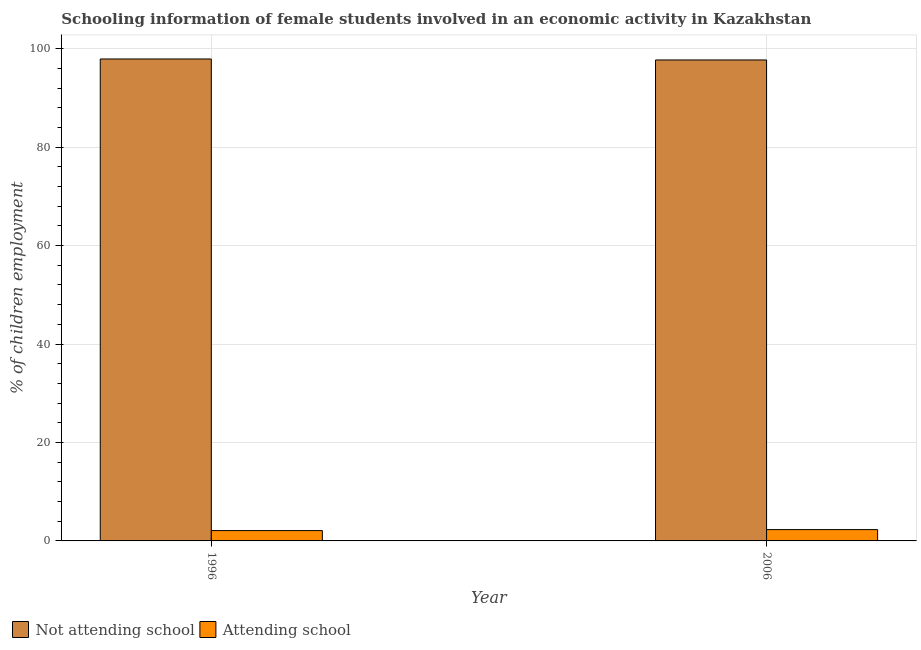How many different coloured bars are there?
Your answer should be very brief. 2. How many bars are there on the 2nd tick from the left?
Give a very brief answer. 2. How many bars are there on the 1st tick from the right?
Keep it short and to the point. 2. In how many cases, is the number of bars for a given year not equal to the number of legend labels?
Ensure brevity in your answer.  0. What is the percentage of employed females who are not attending school in 2006?
Provide a succinct answer. 97.7. Across all years, what is the minimum percentage of employed females who are not attending school?
Make the answer very short. 97.7. What is the total percentage of employed females who are not attending school in the graph?
Your answer should be very brief. 195.6. What is the difference between the percentage of employed females who are attending school in 1996 and that in 2006?
Offer a very short reply. -0.2. What is the difference between the percentage of employed females who are attending school in 2006 and the percentage of employed females who are not attending school in 1996?
Offer a very short reply. 0.2. What is the average percentage of employed females who are attending school per year?
Offer a terse response. 2.2. What is the ratio of the percentage of employed females who are not attending school in 1996 to that in 2006?
Your answer should be compact. 1. Is the percentage of employed females who are not attending school in 1996 less than that in 2006?
Your response must be concise. No. What does the 2nd bar from the left in 2006 represents?
Offer a terse response. Attending school. What does the 1st bar from the right in 2006 represents?
Your answer should be compact. Attending school. Are all the bars in the graph horizontal?
Give a very brief answer. No. What is the difference between two consecutive major ticks on the Y-axis?
Ensure brevity in your answer.  20. Are the values on the major ticks of Y-axis written in scientific E-notation?
Your answer should be very brief. No. Does the graph contain grids?
Your answer should be very brief. Yes. Where does the legend appear in the graph?
Provide a short and direct response. Bottom left. How many legend labels are there?
Make the answer very short. 2. What is the title of the graph?
Your answer should be compact. Schooling information of female students involved in an economic activity in Kazakhstan. Does "2012 US$" appear as one of the legend labels in the graph?
Provide a succinct answer. No. What is the label or title of the Y-axis?
Your response must be concise. % of children employment. What is the % of children employment of Not attending school in 1996?
Your answer should be compact. 97.9. What is the % of children employment of Not attending school in 2006?
Your answer should be very brief. 97.7. Across all years, what is the maximum % of children employment in Not attending school?
Offer a very short reply. 97.9. Across all years, what is the minimum % of children employment of Not attending school?
Ensure brevity in your answer.  97.7. What is the total % of children employment in Not attending school in the graph?
Your response must be concise. 195.6. What is the difference between the % of children employment of Not attending school in 1996 and the % of children employment of Attending school in 2006?
Ensure brevity in your answer.  95.6. What is the average % of children employment in Not attending school per year?
Offer a very short reply. 97.8. What is the average % of children employment in Attending school per year?
Keep it short and to the point. 2.2. In the year 1996, what is the difference between the % of children employment in Not attending school and % of children employment in Attending school?
Your answer should be very brief. 95.8. In the year 2006, what is the difference between the % of children employment of Not attending school and % of children employment of Attending school?
Your answer should be very brief. 95.4. What is the ratio of the % of children employment in Not attending school in 1996 to that in 2006?
Your response must be concise. 1. What is the difference between the highest and the second highest % of children employment in Not attending school?
Your answer should be very brief. 0.2. What is the difference between the highest and the second highest % of children employment in Attending school?
Make the answer very short. 0.2. 